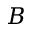<formula> <loc_0><loc_0><loc_500><loc_500>B</formula> 